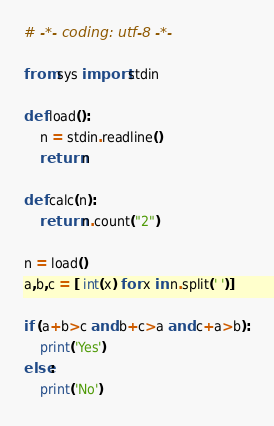Convert code to text. <code><loc_0><loc_0><loc_500><loc_500><_Python_># -*- coding: utf-8 -*-

from sys import stdin

def load():
    n = stdin.readline()
    return n

def calc(n):
    return n.count("2")

n = load()
a,b,c = [ int(x) for x in n.split(' ')]

if (a+b>c and b+c>a and c+a>b):
    print('Yes')
else:
    print('No')</code> 